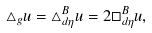<formula> <loc_0><loc_0><loc_500><loc_500>\triangle _ { g } u = \triangle ^ { B } _ { d \eta } u = 2 \square ^ { B } _ { d \eta } u ,</formula> 